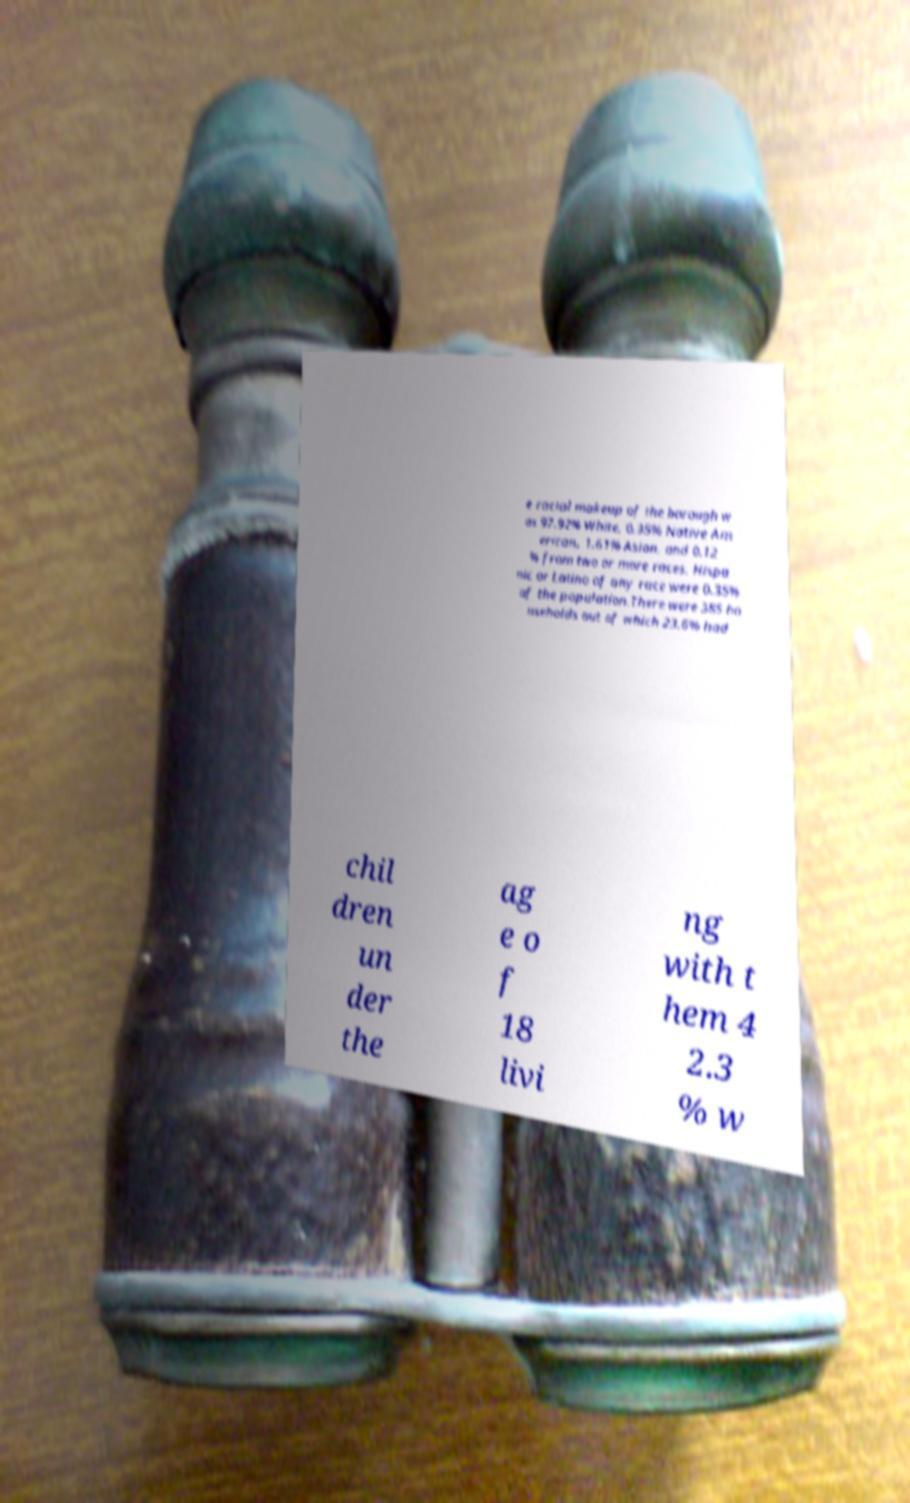Can you read and provide the text displayed in the image?This photo seems to have some interesting text. Can you extract and type it out for me? e racial makeup of the borough w as 97.92% White, 0.35% Native Am erican, 1.61% Asian, and 0.12 % from two or more races. Hispa nic or Latino of any race were 0.35% of the population.There were 385 ho useholds out of which 23.6% had chil dren un der the ag e o f 18 livi ng with t hem 4 2.3 % w 